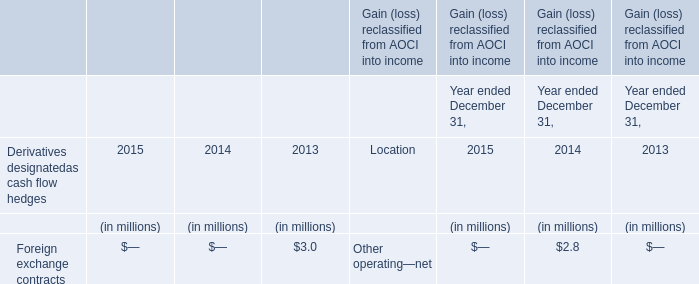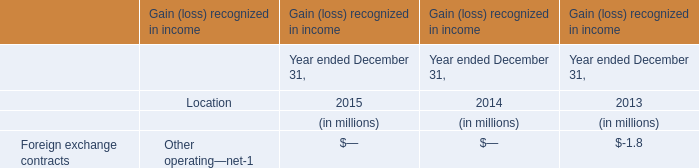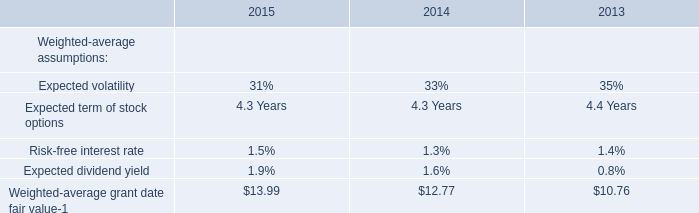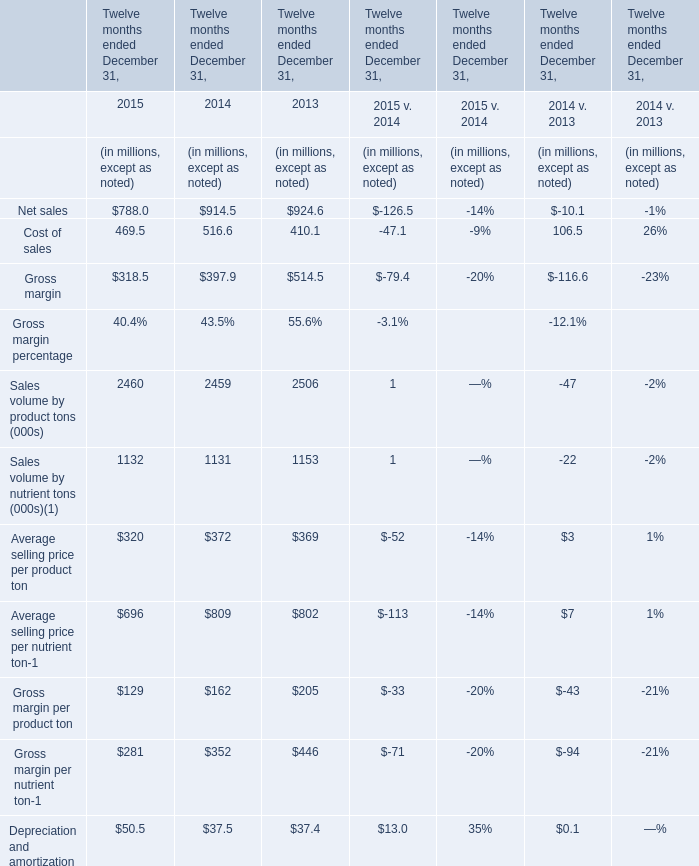Does the value of Net sales in 2015 greater than that in 2014? 
Answer: no. 